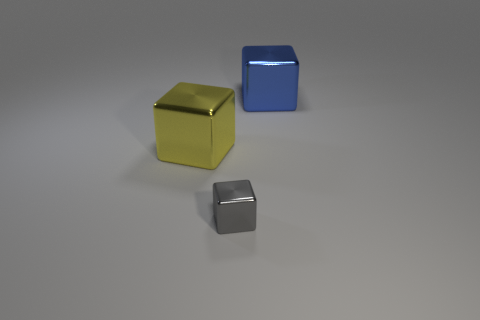What is the color of the other big object that is the same material as the blue thing?
Offer a very short reply. Yellow. The big yellow thing is what shape?
Make the answer very short. Cube. There is a large object in front of the big blue metal block; what is it made of?
Make the answer very short. Metal. Are there any large shiny cubes that have the same color as the small shiny cube?
Your answer should be very brief. No. The metal cube behind the yellow shiny object is what color?
Make the answer very short. Blue. There is a shiny thing that is behind the big yellow thing; is there a thing in front of it?
Keep it short and to the point. Yes. What number of things are things behind the gray shiny cube or metallic cylinders?
Keep it short and to the point. 2. Is there any other thing that is the same size as the gray cube?
Give a very brief answer. No. There is a block behind the large block on the left side of the blue shiny cube; what is its material?
Make the answer very short. Metal. Are there the same number of small gray objects behind the tiny gray shiny thing and large yellow metal cubes that are in front of the yellow metallic cube?
Your answer should be very brief. Yes. 